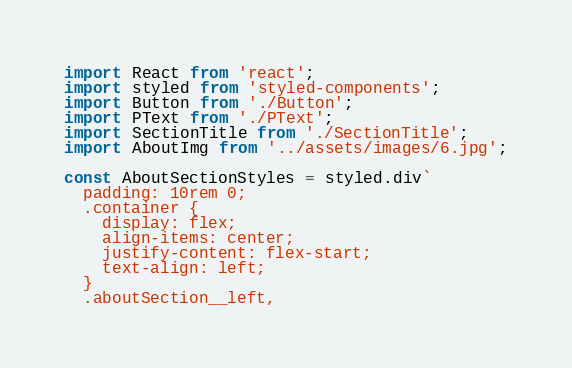<code> <loc_0><loc_0><loc_500><loc_500><_JavaScript_>import React from 'react';
import styled from 'styled-components';
import Button from './Button';
import PText from './PText';
import SectionTitle from './SectionTitle';
import AboutImg from '../assets/images/6.jpg';

const AboutSectionStyles = styled.div`
  padding: 10rem 0;
  .container {
    display: flex;
    align-items: center;
    justify-content: flex-start;
    text-align: left;
  }
  .aboutSection__left,</code> 